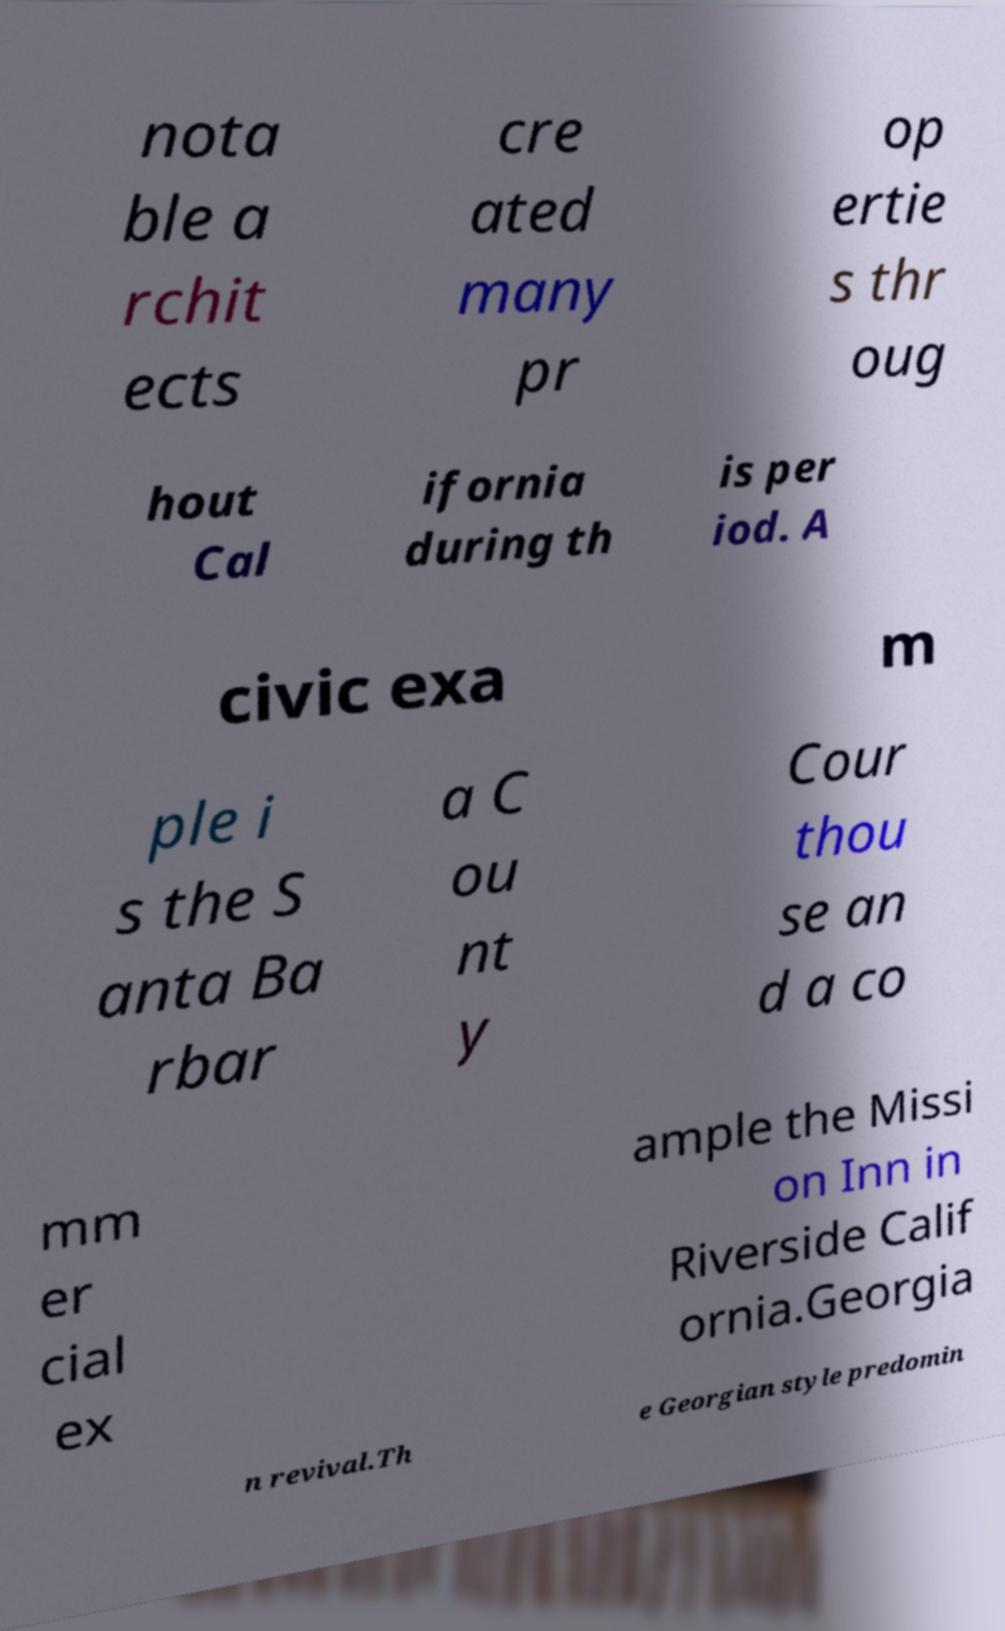Please identify and transcribe the text found in this image. nota ble a rchit ects cre ated many pr op ertie s thr oug hout Cal ifornia during th is per iod. A civic exa m ple i s the S anta Ba rbar a C ou nt y Cour thou se an d a co mm er cial ex ample the Missi on Inn in Riverside Calif ornia.Georgia n revival.Th e Georgian style predomin 